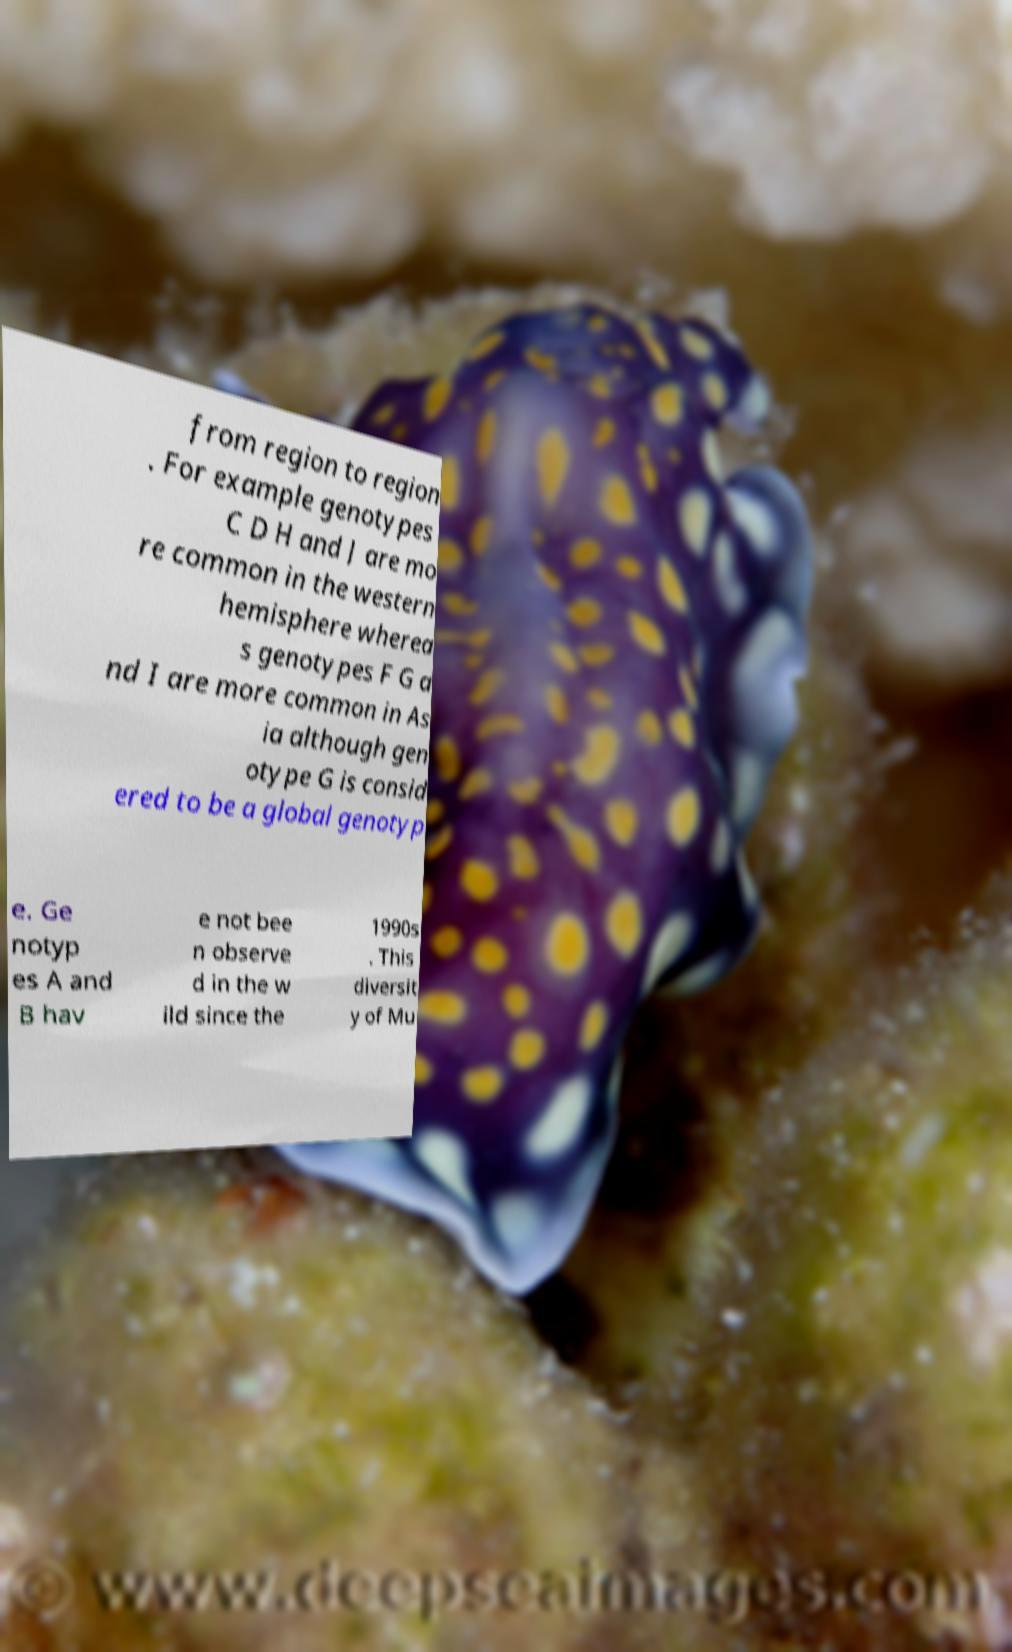Please identify and transcribe the text found in this image. from region to region . For example genotypes C D H and J are mo re common in the western hemisphere wherea s genotypes F G a nd I are more common in As ia although gen otype G is consid ered to be a global genotyp e. Ge notyp es A and B hav e not bee n observe d in the w ild since the 1990s . This diversit y of Mu 